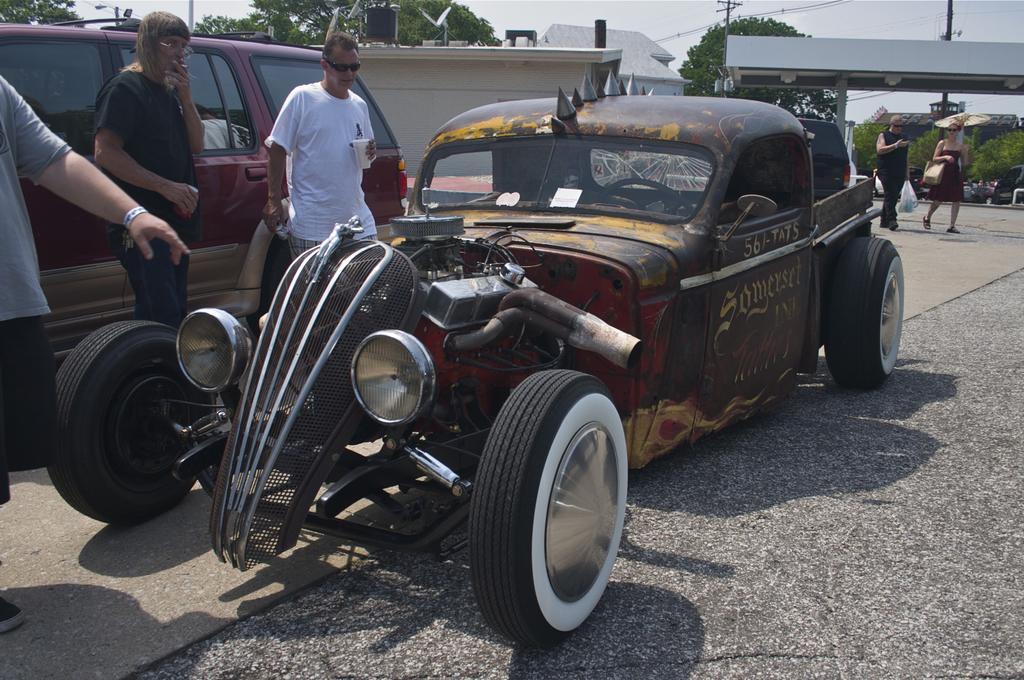Please provide a concise description of this image. In this picture I can see the car, beside that I can see some people who are standing. In the back I can see two persons who are walking on the road. In the background I can see many trees, poles, banners, electric poles, wires and buildings. At the top I can see the sky and clouds. On the left I can see another white color car. 